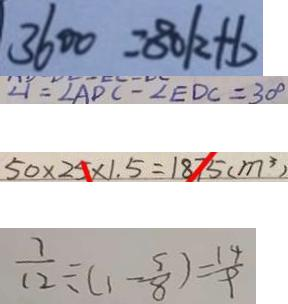Convert formula to latex. <formula><loc_0><loc_0><loc_500><loc_500>3 6 0 0 = 8 0 k + b 
 \angle 1 = \angle A D C - \angle E D C = 3 0 ^ { \circ } 
 5 0 \times 2 5 \times 1 . 5 = 1 8 7 5 ( m ^ { 3 } ) 
 \frac { 7 } { 1 2 } \div ( 1 - \frac { 5 } { 8 } ) = \frac { 1 4 } { 9 }</formula> 